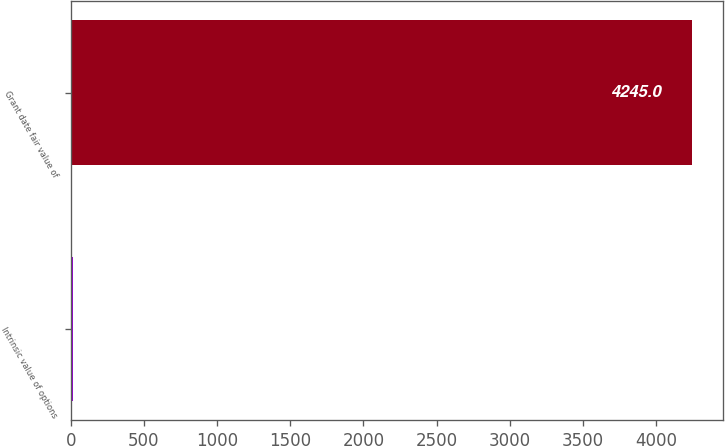<chart> <loc_0><loc_0><loc_500><loc_500><bar_chart><fcel>Intrinsic value of options<fcel>Grant date fair value of<nl><fcel>17<fcel>4245<nl></chart> 